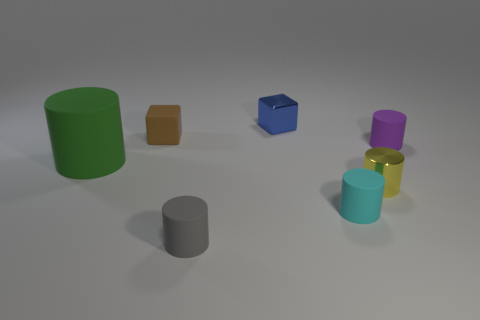Subtract all tiny cyan rubber cylinders. How many cylinders are left? 4 Subtract all gray cylinders. How many cylinders are left? 4 Subtract all blue cylinders. Subtract all yellow blocks. How many cylinders are left? 5 Add 1 big things. How many objects exist? 8 Subtract all blocks. How many objects are left? 5 Subtract 0 green cubes. How many objects are left? 7 Subtract all big green rubber cylinders. Subtract all small cyan cylinders. How many objects are left? 5 Add 5 big green objects. How many big green objects are left? 6 Add 3 red shiny things. How many red shiny things exist? 3 